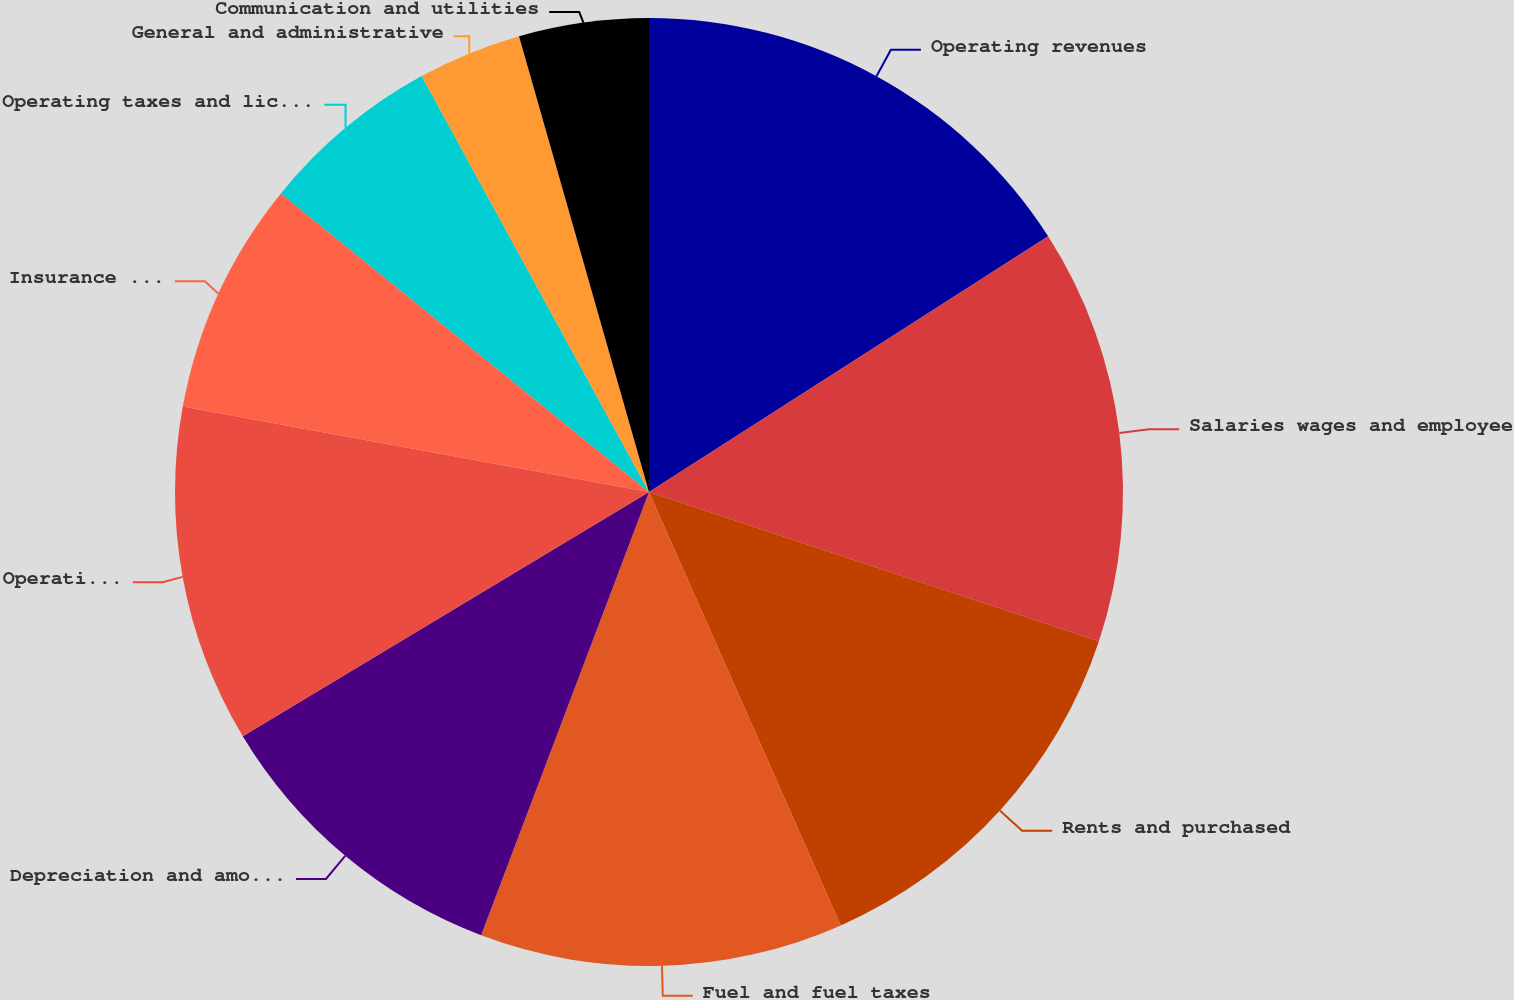Convert chart to OTSL. <chart><loc_0><loc_0><loc_500><loc_500><pie_chart><fcel>Operating revenues<fcel>Salaries wages and employee<fcel>Rents and purchased<fcel>Fuel and fuel taxes<fcel>Depreciation and amortization<fcel>Operating supplies and<fcel>Insurance and claims<fcel>Operating taxes and licenses<fcel>General and administrative<fcel>Communication and utilities<nl><fcel>15.93%<fcel>14.16%<fcel>13.27%<fcel>12.39%<fcel>10.62%<fcel>11.5%<fcel>7.96%<fcel>6.19%<fcel>3.54%<fcel>4.42%<nl></chart> 